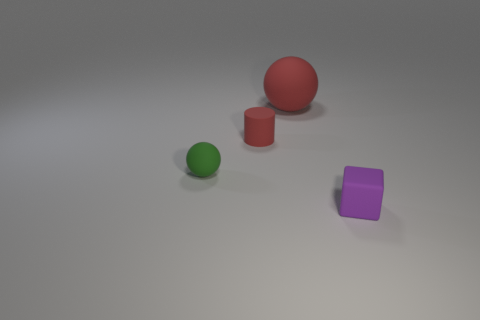There is a big thing; does it have the same shape as the tiny matte thing behind the tiny green matte sphere?
Make the answer very short. No. What number of tiny objects are purple things or balls?
Make the answer very short. 2. Is the number of tiny purple things on the left side of the big red object less than the number of tiny matte things left of the red cylinder?
Provide a short and direct response. Yes. What number of things are either tiny matte balls or big cylinders?
Your response must be concise. 1. How many green matte spheres are to the right of the green matte ball?
Provide a short and direct response. 0. Does the tiny matte cube have the same color as the small rubber sphere?
Ensure brevity in your answer.  No. There is a big thing that is the same material as the cylinder; what shape is it?
Offer a terse response. Sphere. Is the shape of the tiny object on the right side of the red rubber sphere the same as  the small green thing?
Give a very brief answer. No. How many green things are either matte cubes or large metal spheres?
Provide a succinct answer. 0. Is the number of green matte objects behind the small green rubber ball the same as the number of red spheres to the right of the purple object?
Offer a terse response. Yes. 